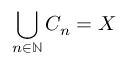Convert formula to latex. <formula><loc_0><loc_0><loc_500><loc_500>\bigcup _ { n \in \mathbb { N } } C _ { n } = X</formula> 